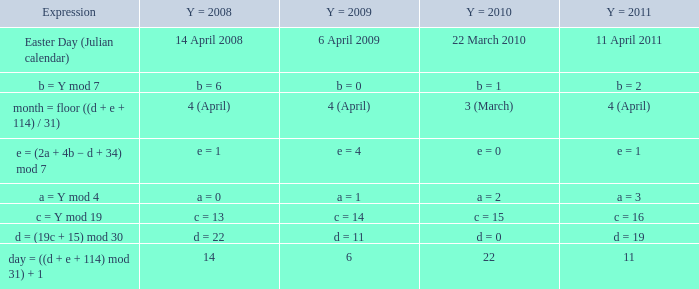What is the y = 2011 when the expression is month = floor ((d + e + 114) / 31)? 4 (April). 